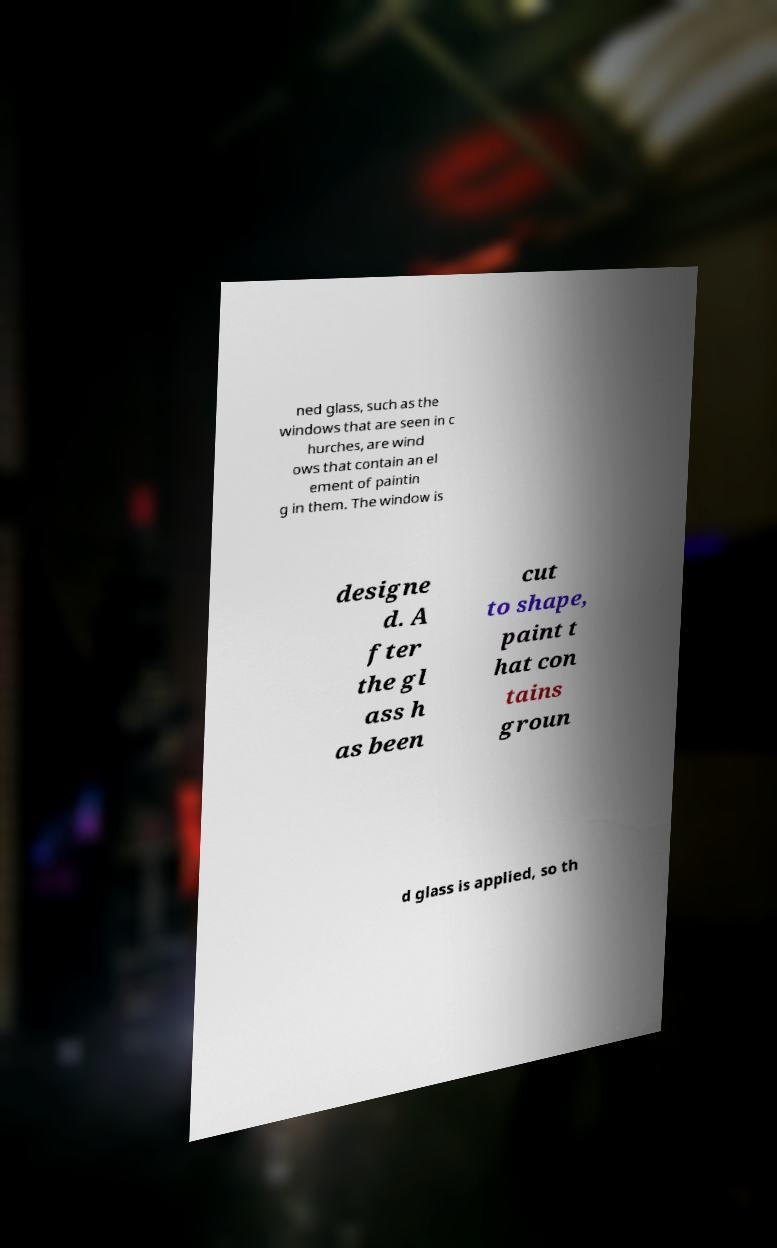Can you accurately transcribe the text from the provided image for me? ned glass, such as the windows that are seen in c hurches, are wind ows that contain an el ement of paintin g in them. The window is designe d. A fter the gl ass h as been cut to shape, paint t hat con tains groun d glass is applied, so th 